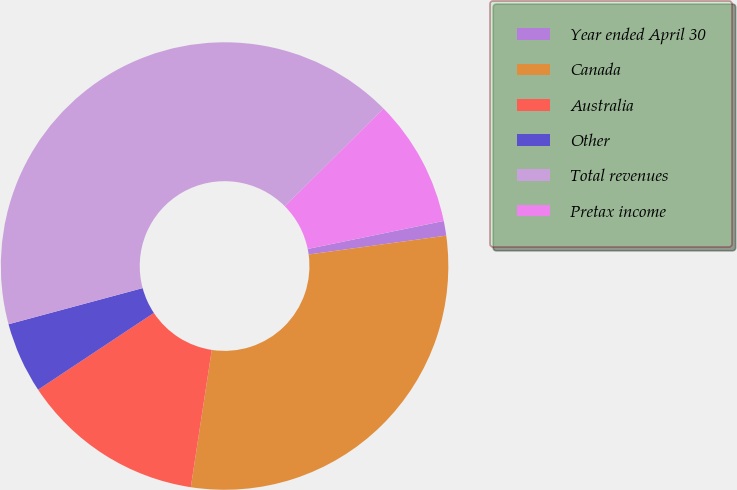<chart> <loc_0><loc_0><loc_500><loc_500><pie_chart><fcel>Year ended April 30<fcel>Canada<fcel>Australia<fcel>Other<fcel>Total revenues<fcel>Pretax income<nl><fcel>1.06%<fcel>29.58%<fcel>13.27%<fcel>5.13%<fcel>41.76%<fcel>9.2%<nl></chart> 